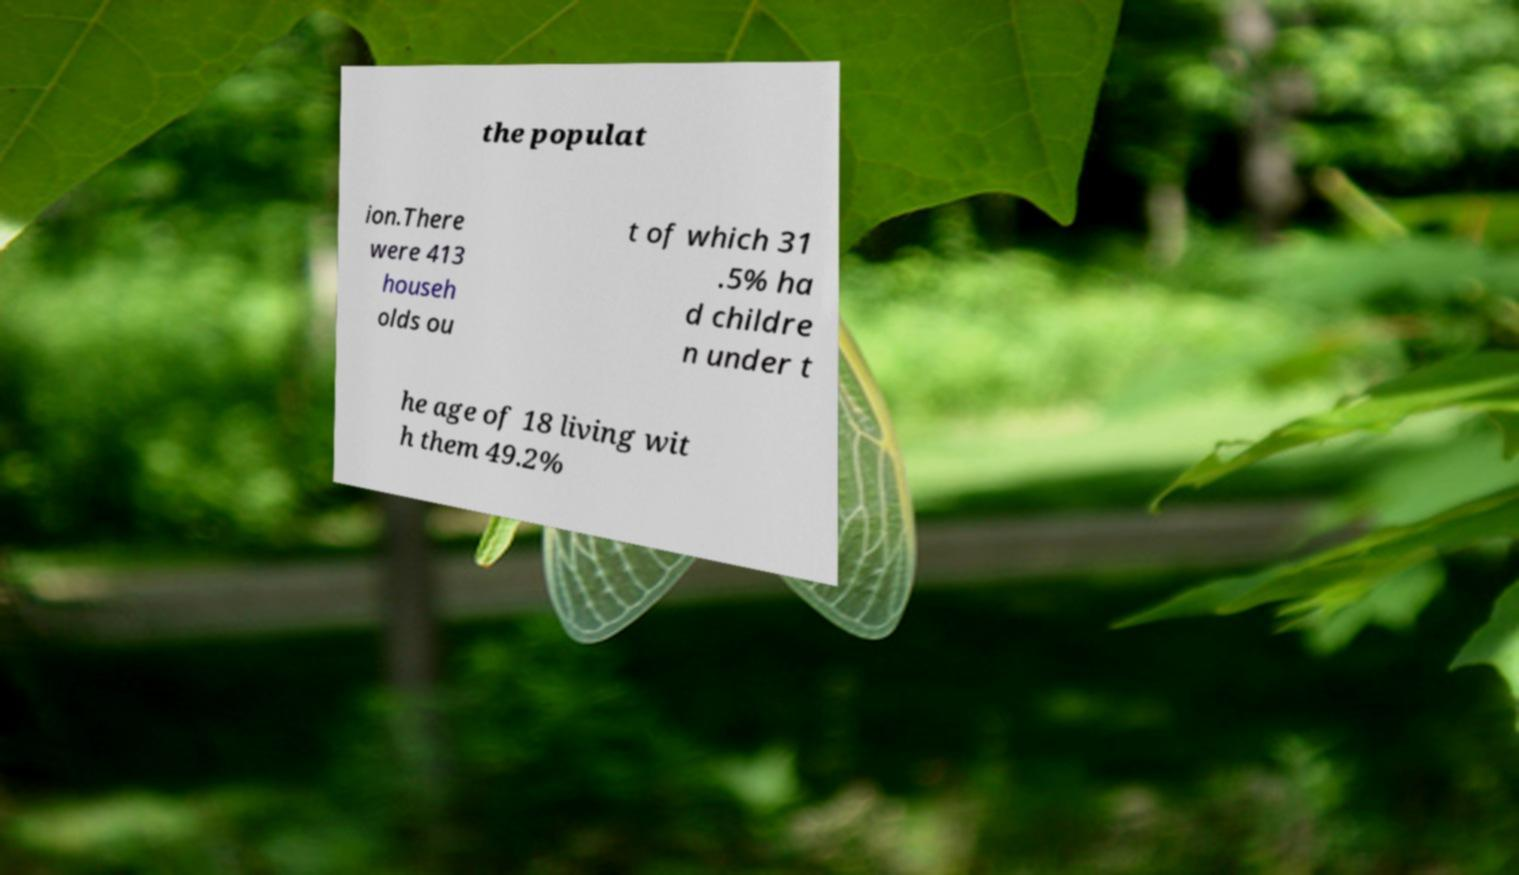Could you extract and type out the text from this image? the populat ion.There were 413 househ olds ou t of which 31 .5% ha d childre n under t he age of 18 living wit h them 49.2% 